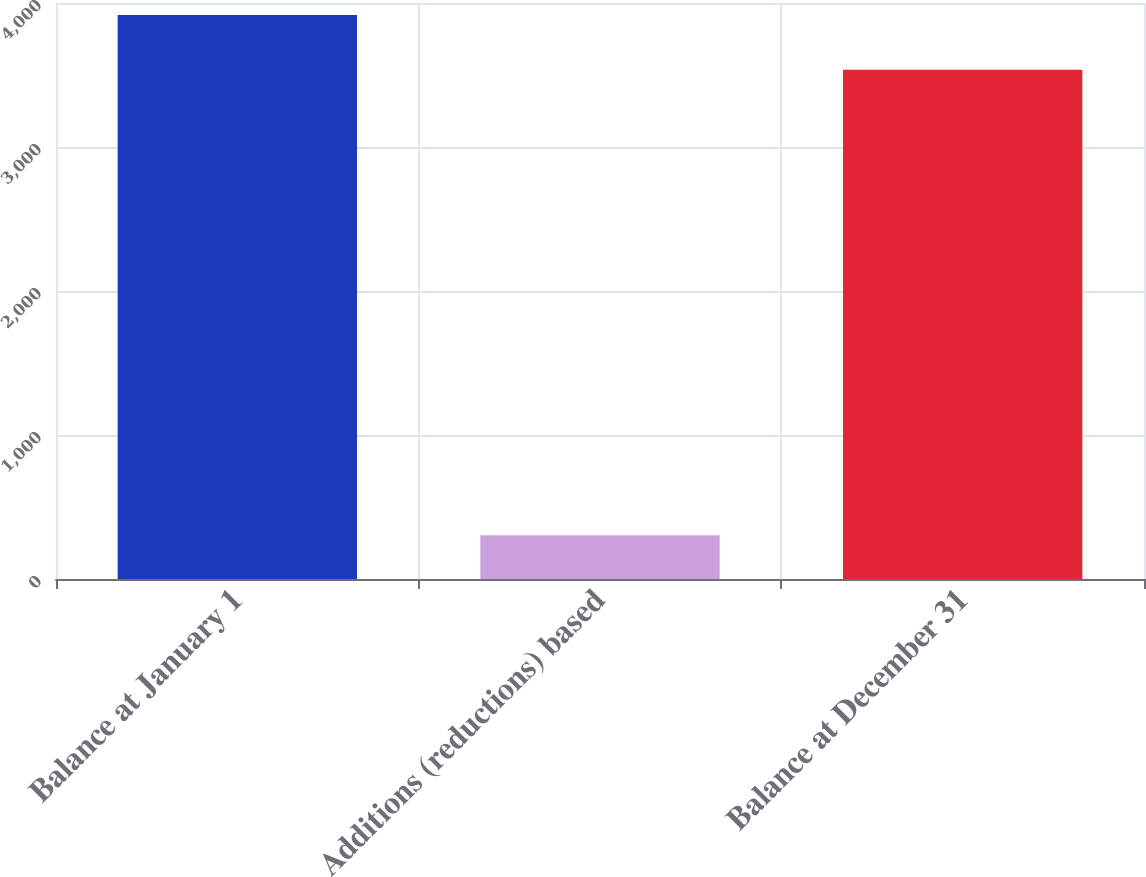Convert chart to OTSL. <chart><loc_0><loc_0><loc_500><loc_500><bar_chart><fcel>Balance at January 1<fcel>Additions (reductions) based<fcel>Balance at December 31<nl><fcel>3917<fcel>303<fcel>3536<nl></chart> 